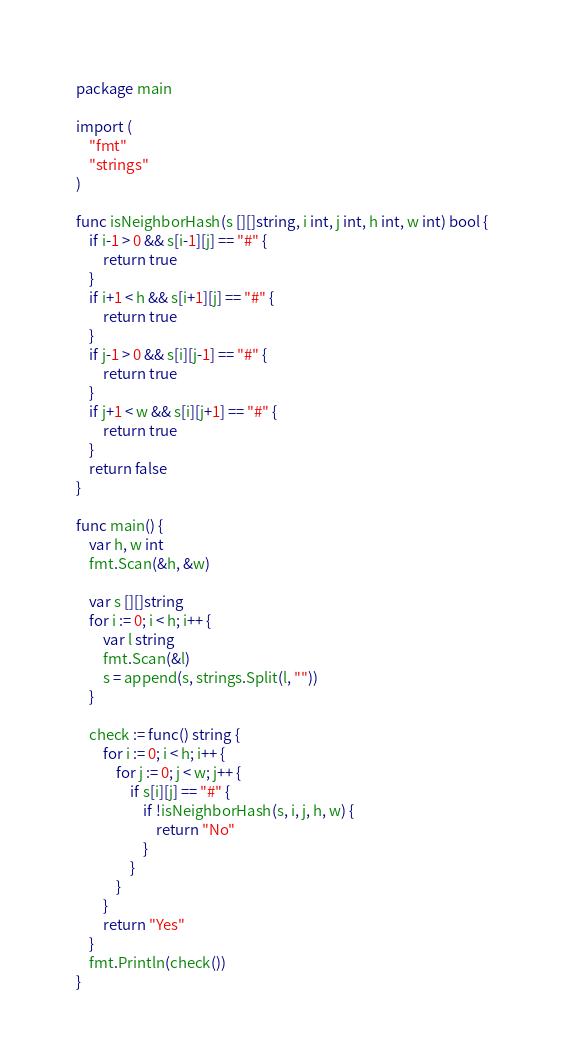Convert code to text. <code><loc_0><loc_0><loc_500><loc_500><_Go_>package main

import (
	"fmt"
	"strings"
)

func isNeighborHash(s [][]string, i int, j int, h int, w int) bool {
	if i-1 > 0 && s[i-1][j] == "#" {
		return true
	}
	if i+1 < h && s[i+1][j] == "#" {
		return true
	}
	if j-1 > 0 && s[i][j-1] == "#" {
		return true
	}
	if j+1 < w && s[i][j+1] == "#" {
		return true
	}
	return false
}

func main() {
	var h, w int
	fmt.Scan(&h, &w)

	var s [][]string
	for i := 0; i < h; i++ {
		var l string
		fmt.Scan(&l)
		s = append(s, strings.Split(l, ""))
	}

	check := func() string {
		for i := 0; i < h; i++ {
			for j := 0; j < w; j++ {
				if s[i][j] == "#" {
					if !isNeighborHash(s, i, j, h, w) {
						return "No"
					}
				}
			}
		}
		return "Yes"
	}
	fmt.Println(check())
}</code> 